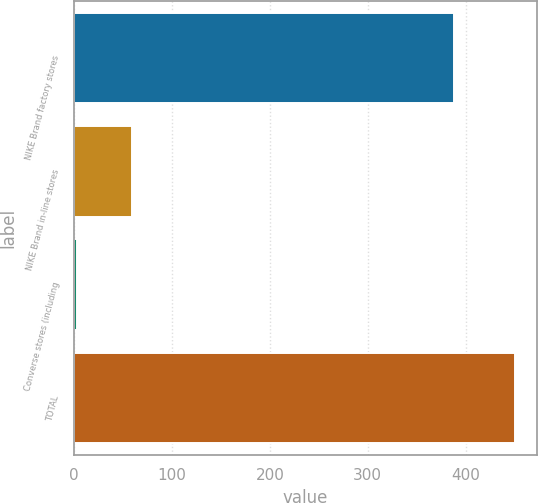Convert chart to OTSL. <chart><loc_0><loc_0><loc_500><loc_500><bar_chart><fcel>NIKE Brand factory stores<fcel>NIKE Brand in-line stores<fcel>Converse stores (including<fcel>TOTAL<nl><fcel>388<fcel>59<fcel>3<fcel>450<nl></chart> 